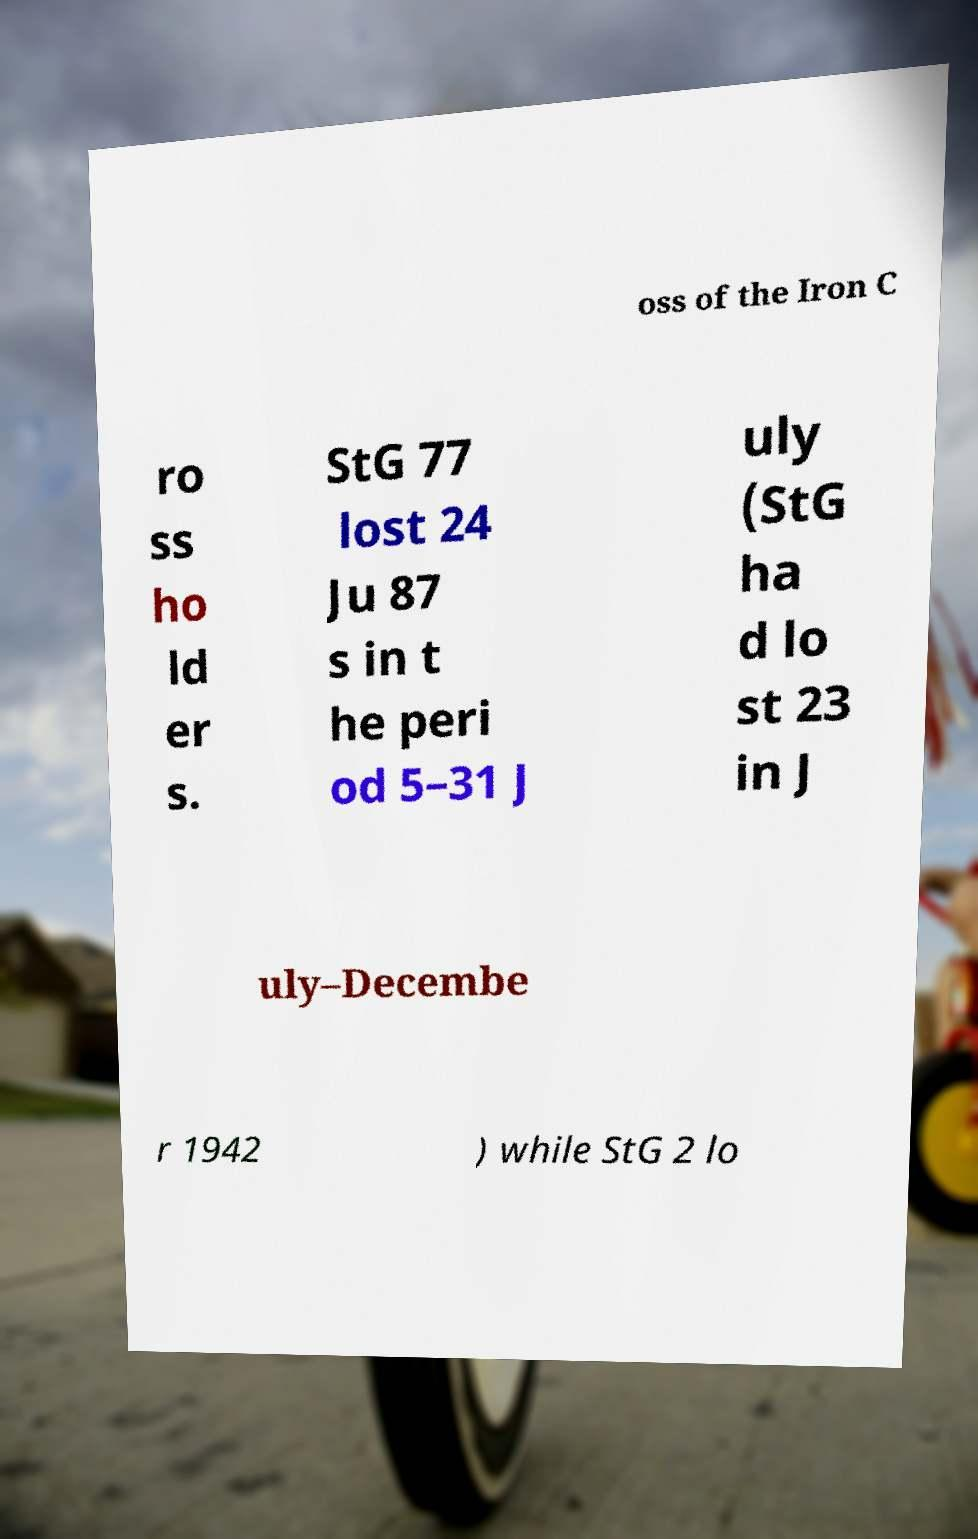Please identify and transcribe the text found in this image. oss of the Iron C ro ss ho ld er s. StG 77 lost 24 Ju 87 s in t he peri od 5–31 J uly (StG ha d lo st 23 in J uly–Decembe r 1942 ) while StG 2 lo 